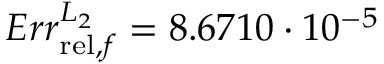Convert formula to latex. <formula><loc_0><loc_0><loc_500><loc_500>E r r _ { r e l , f } ^ { L _ { 2 } } = 8 . 6 7 1 0 \cdot 1 0 ^ { - 5 }</formula> 